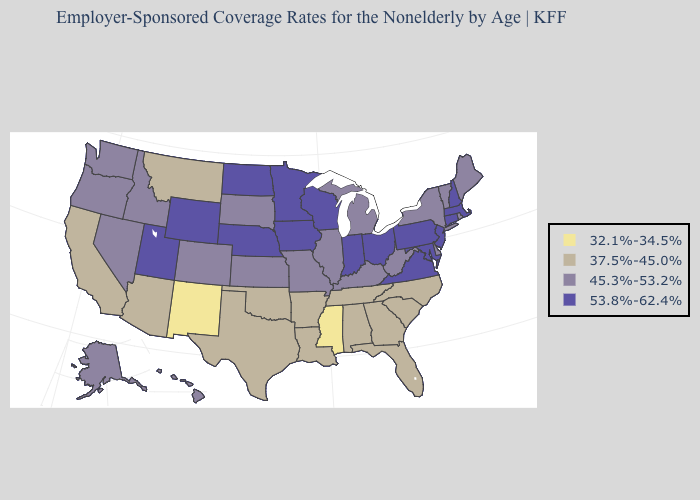What is the lowest value in the Northeast?
Write a very short answer. 45.3%-53.2%. Name the states that have a value in the range 53.8%-62.4%?
Keep it brief. Connecticut, Indiana, Iowa, Maryland, Massachusetts, Minnesota, Nebraska, New Hampshire, New Jersey, North Dakota, Ohio, Pennsylvania, Utah, Virginia, Wisconsin, Wyoming. Is the legend a continuous bar?
Write a very short answer. No. Does Maine have the highest value in the Northeast?
Keep it brief. No. Name the states that have a value in the range 37.5%-45.0%?
Answer briefly. Alabama, Arizona, Arkansas, California, Florida, Georgia, Louisiana, Montana, North Carolina, Oklahoma, South Carolina, Tennessee, Texas. Name the states that have a value in the range 53.8%-62.4%?
Concise answer only. Connecticut, Indiana, Iowa, Maryland, Massachusetts, Minnesota, Nebraska, New Hampshire, New Jersey, North Dakota, Ohio, Pennsylvania, Utah, Virginia, Wisconsin, Wyoming. What is the value of Rhode Island?
Short answer required. 45.3%-53.2%. Which states have the lowest value in the MidWest?
Be succinct. Illinois, Kansas, Michigan, Missouri, South Dakota. Does Wisconsin have the same value as Washington?
Keep it brief. No. Is the legend a continuous bar?
Quick response, please. No. Name the states that have a value in the range 45.3%-53.2%?
Write a very short answer. Alaska, Colorado, Delaware, Hawaii, Idaho, Illinois, Kansas, Kentucky, Maine, Michigan, Missouri, Nevada, New York, Oregon, Rhode Island, South Dakota, Vermont, Washington, West Virginia. What is the value of New Jersey?
Write a very short answer. 53.8%-62.4%. Which states have the highest value in the USA?
Keep it brief. Connecticut, Indiana, Iowa, Maryland, Massachusetts, Minnesota, Nebraska, New Hampshire, New Jersey, North Dakota, Ohio, Pennsylvania, Utah, Virginia, Wisconsin, Wyoming. Does Alabama have the same value as Washington?
Keep it brief. No. What is the value of New Mexico?
Concise answer only. 32.1%-34.5%. 